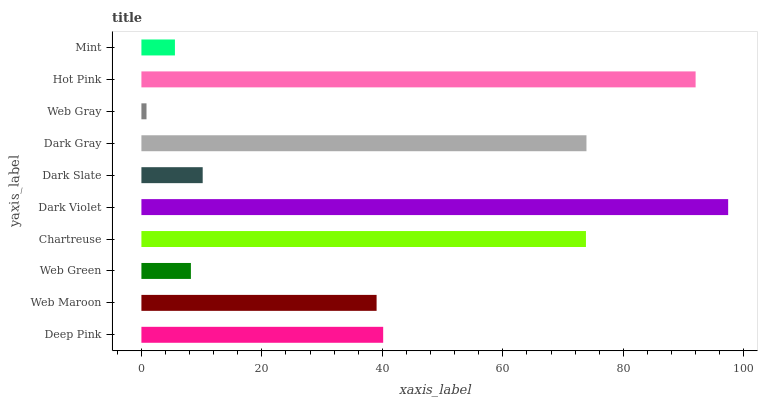Is Web Gray the minimum?
Answer yes or no. Yes. Is Dark Violet the maximum?
Answer yes or no. Yes. Is Web Maroon the minimum?
Answer yes or no. No. Is Web Maroon the maximum?
Answer yes or no. No. Is Deep Pink greater than Web Maroon?
Answer yes or no. Yes. Is Web Maroon less than Deep Pink?
Answer yes or no. Yes. Is Web Maroon greater than Deep Pink?
Answer yes or no. No. Is Deep Pink less than Web Maroon?
Answer yes or no. No. Is Deep Pink the high median?
Answer yes or no. Yes. Is Web Maroon the low median?
Answer yes or no. Yes. Is Hot Pink the high median?
Answer yes or no. No. Is Web Green the low median?
Answer yes or no. No. 